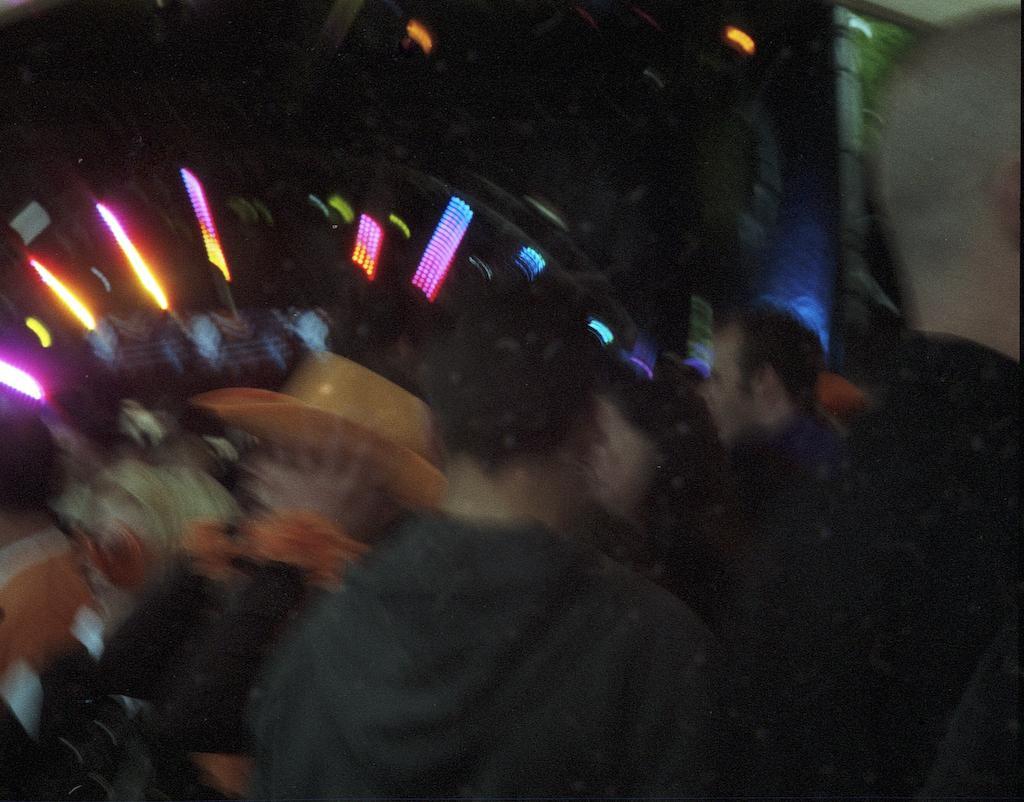How would you summarize this image in a sentence or two? In this picture we can see a group of people are standing. On the left side of the image we can see a person is wearing a cap. In the background of the image we can see the lights. 